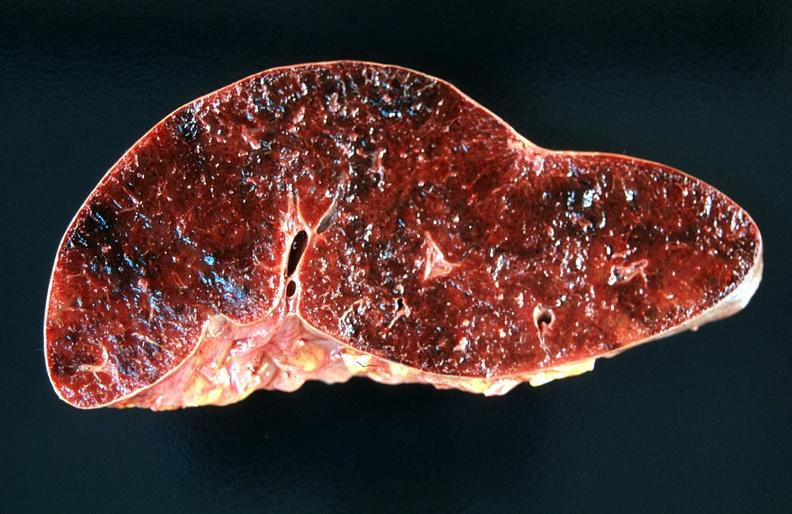what is present?
Answer the question using a single word or phrase. Hematologic 